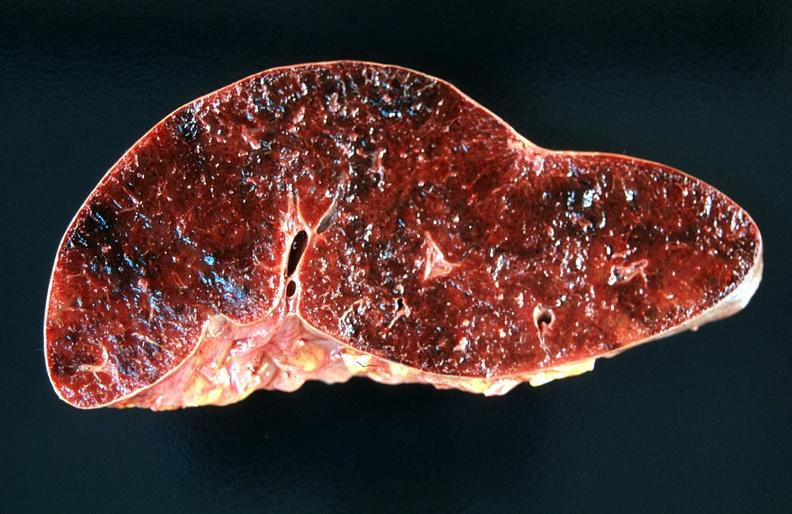what is present?
Answer the question using a single word or phrase. Hematologic 